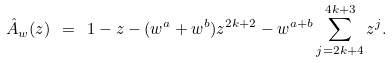Convert formula to latex. <formula><loc_0><loc_0><loc_500><loc_500>\hat { A } _ { w } ( z ) \ = \ 1 - z - ( w ^ { a } + w ^ { b } ) z ^ { 2 k + 2 } - w ^ { a + b } \sum _ { j = 2 k + 4 } ^ { 4 k + 3 } z ^ { j } .</formula> 